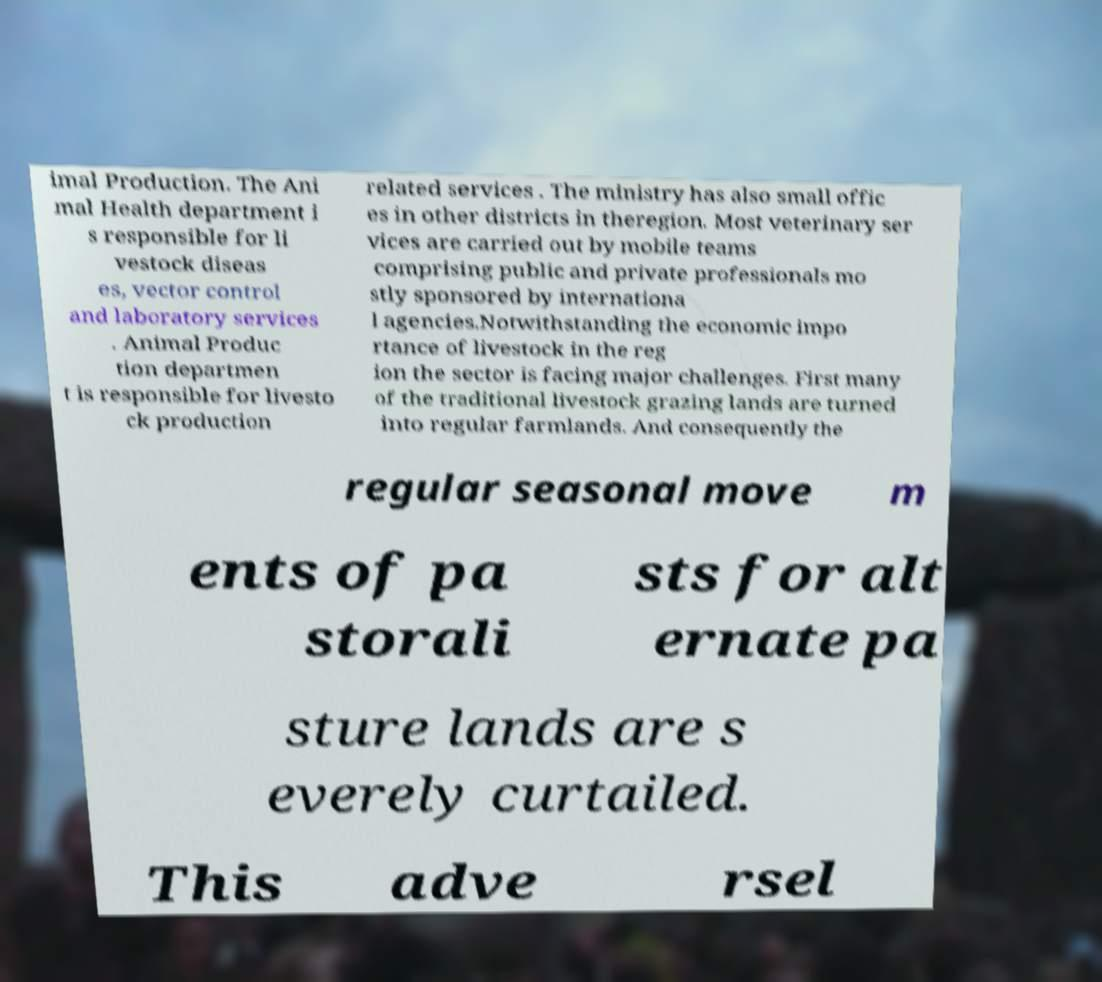Please read and relay the text visible in this image. What does it say? imal Production. The Ani mal Health department i s responsible for li vestock diseas es, vector control and laboratory services . Animal Produc tion departmen t is responsible for livesto ck production related services . The ministry has also small offic es in other districts in theregion. Most veterinary ser vices are carried out by mobile teams comprising public and private professionals mo stly sponsored by internationa l agencies.Notwithstanding the economic impo rtance of livestock in the reg ion the sector is facing major challenges. First many of the traditional livestock grazing lands are turned into regular farmlands. And consequently the regular seasonal move m ents of pa storali sts for alt ernate pa sture lands are s everely curtailed. This adve rsel 